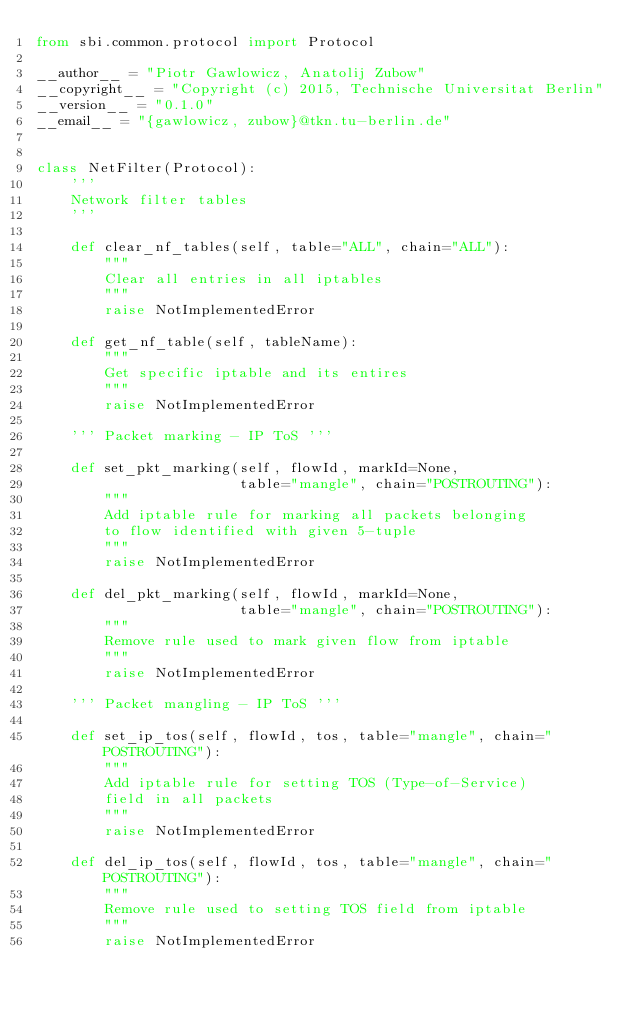Convert code to text. <code><loc_0><loc_0><loc_500><loc_500><_Python_>from sbi.common.protocol import Protocol

__author__ = "Piotr Gawlowicz, Anatolij Zubow"
__copyright__ = "Copyright (c) 2015, Technische Universitat Berlin"
__version__ = "0.1.0"
__email__ = "{gawlowicz, zubow}@tkn.tu-berlin.de"


class NetFilter(Protocol):
    '''
    Network filter tables
    '''

    def clear_nf_tables(self, table="ALL", chain="ALL"):
        """
        Clear all entries in all iptables
        """
        raise NotImplementedError

    def get_nf_table(self, tableName):
        """
        Get specific iptable and its entires
        """
        raise NotImplementedError

    ''' Packet marking - IP ToS '''

    def set_pkt_marking(self, flowId, markId=None,
                        table="mangle", chain="POSTROUTING"):
        """
        Add iptable rule for marking all packets belonging
        to flow identified with given 5-tuple
        """
        raise NotImplementedError

    def del_pkt_marking(self, flowId, markId=None,
                        table="mangle", chain="POSTROUTING"):
        """
        Remove rule used to mark given flow from iptable
        """
        raise NotImplementedError

    ''' Packet mangling - IP ToS '''

    def set_ip_tos(self, flowId, tos, table="mangle", chain="POSTROUTING"):
        """
        Add iptable rule for setting TOS (Type-of-Service)
        field in all packets
        """
        raise NotImplementedError

    def del_ip_tos(self, flowId, tos, table="mangle", chain="POSTROUTING"):
        """
        Remove rule used to setting TOS field from iptable
        """
        raise NotImplementedError
</code> 